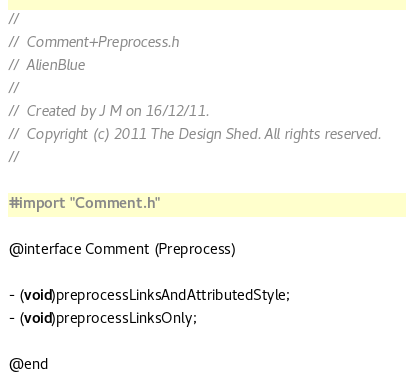<code> <loc_0><loc_0><loc_500><loc_500><_C_>//
//  Comment+Preprocess.h
//  AlienBlue
//
//  Created by J M on 16/12/11.
//  Copyright (c) 2011 The Design Shed. All rights reserved.
//

#import "Comment.h"

@interface Comment (Preprocess)

- (void)preprocessLinksAndAttributedStyle;
- (void)preprocessLinksOnly;

@end
</code> 